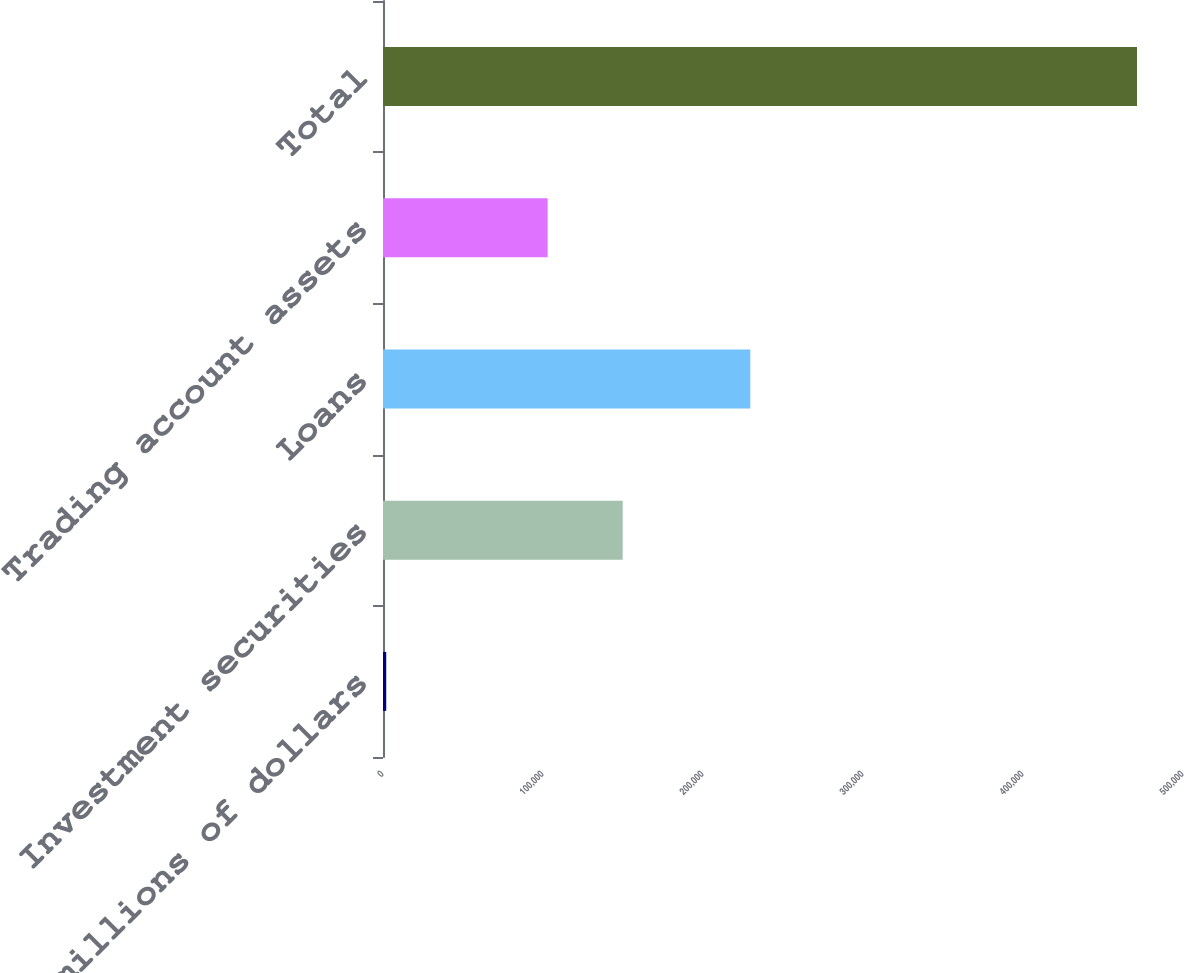Convert chart. <chart><loc_0><loc_0><loc_500><loc_500><bar_chart><fcel>In millions of dollars<fcel>Investment securities<fcel>Loans<fcel>Trading account assets<fcel>Total<nl><fcel>2017<fcel>149815<fcel>229552<fcel>102892<fcel>471251<nl></chart> 